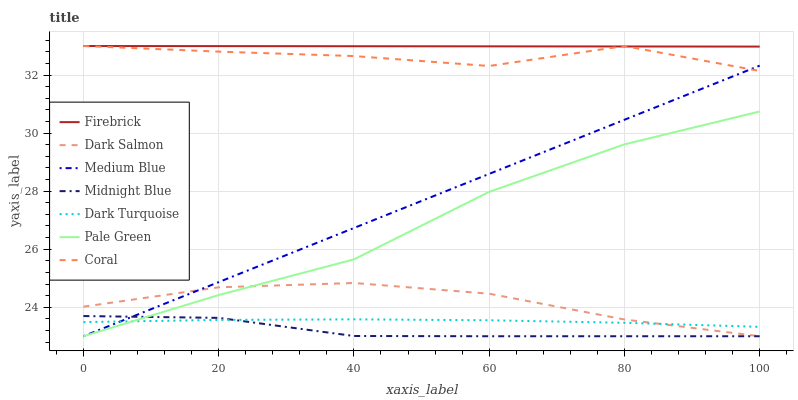Does Midnight Blue have the minimum area under the curve?
Answer yes or no. Yes. Does Firebrick have the maximum area under the curve?
Answer yes or no. Yes. Does Dark Turquoise have the minimum area under the curve?
Answer yes or no. No. Does Dark Turquoise have the maximum area under the curve?
Answer yes or no. No. Is Medium Blue the smoothest?
Answer yes or no. Yes. Is Coral the roughest?
Answer yes or no. Yes. Is Dark Turquoise the smoothest?
Answer yes or no. No. Is Dark Turquoise the roughest?
Answer yes or no. No. Does Midnight Blue have the lowest value?
Answer yes or no. Yes. Does Dark Turquoise have the lowest value?
Answer yes or no. No. Does Coral have the highest value?
Answer yes or no. Yes. Does Dark Turquoise have the highest value?
Answer yes or no. No. Is Midnight Blue less than Coral?
Answer yes or no. Yes. Is Firebrick greater than Pale Green?
Answer yes or no. Yes. Does Coral intersect Firebrick?
Answer yes or no. Yes. Is Coral less than Firebrick?
Answer yes or no. No. Is Coral greater than Firebrick?
Answer yes or no. No. Does Midnight Blue intersect Coral?
Answer yes or no. No. 